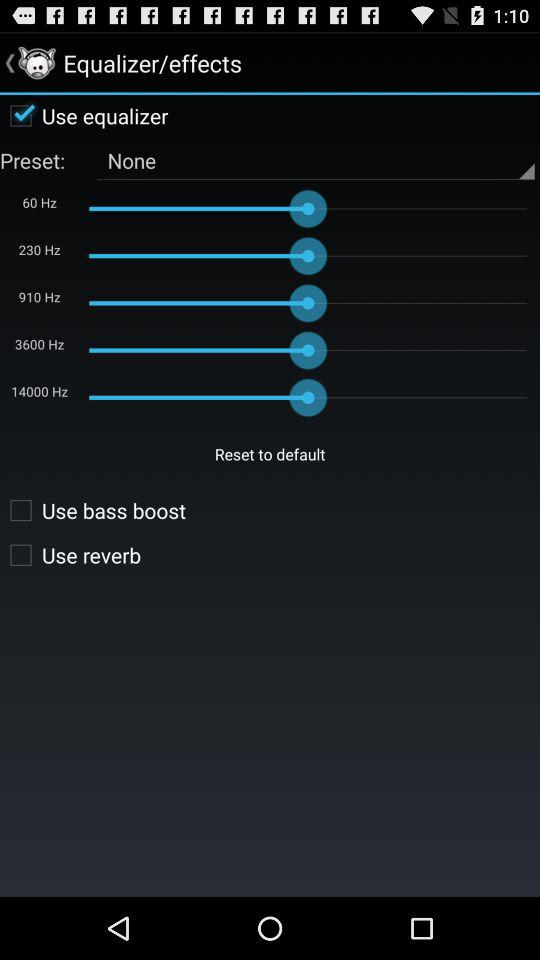What is the selected "Preset"? The selected "Preset" is none. 